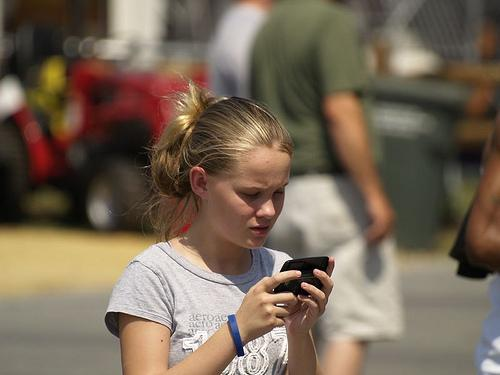What phone feature is she using? Please explain your reasoning. slide. The phone appears to be held sideways and slid up to be able to type a message on a physical keyboard. 